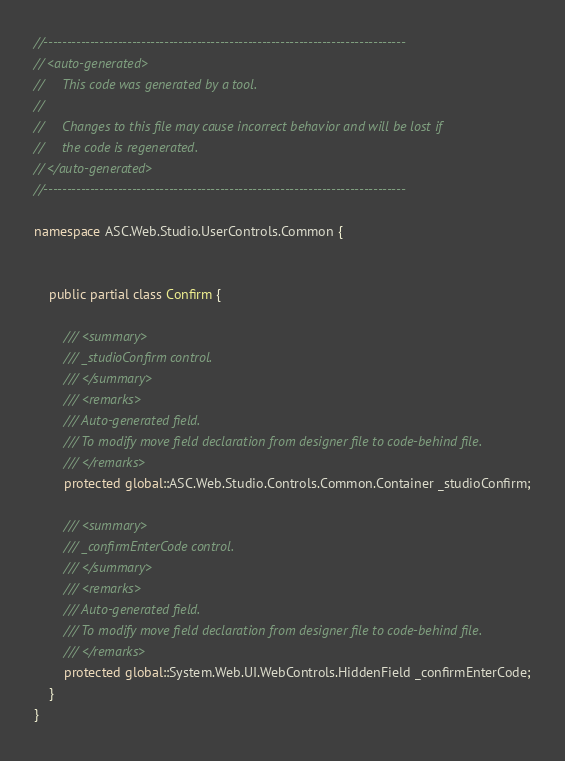Convert code to text. <code><loc_0><loc_0><loc_500><loc_500><_C#_>//------------------------------------------------------------------------------
// <auto-generated>
//     This code was generated by a tool.
//
//     Changes to this file may cause incorrect behavior and will be lost if
//     the code is regenerated. 
// </auto-generated>
//------------------------------------------------------------------------------

namespace ASC.Web.Studio.UserControls.Common {
    
    
    public partial class Confirm {
        
        /// <summary>
        /// _studioConfirm control.
        /// </summary>
        /// <remarks>
        /// Auto-generated field.
        /// To modify move field declaration from designer file to code-behind file.
        /// </remarks>
        protected global::ASC.Web.Studio.Controls.Common.Container _studioConfirm;
        
        /// <summary>
        /// _confirmEnterCode control.
        /// </summary>
        /// <remarks>
        /// Auto-generated field.
        /// To modify move field declaration from designer file to code-behind file.
        /// </remarks>
        protected global::System.Web.UI.WebControls.HiddenField _confirmEnterCode;
    }
}
</code> 